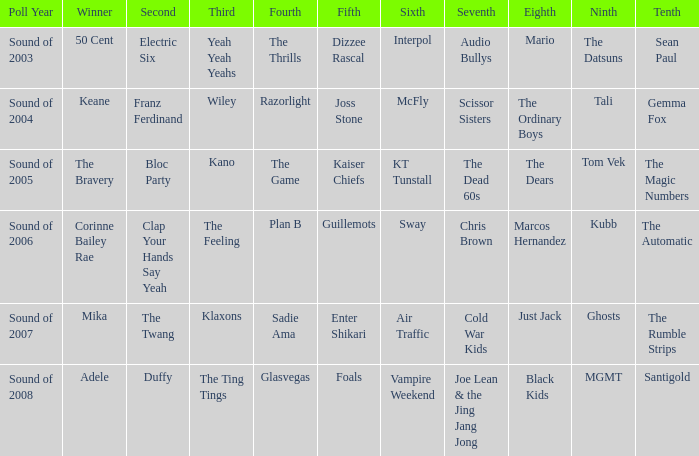Who occupied 4th position when in 6th is air traffic? Sadie Ama. 